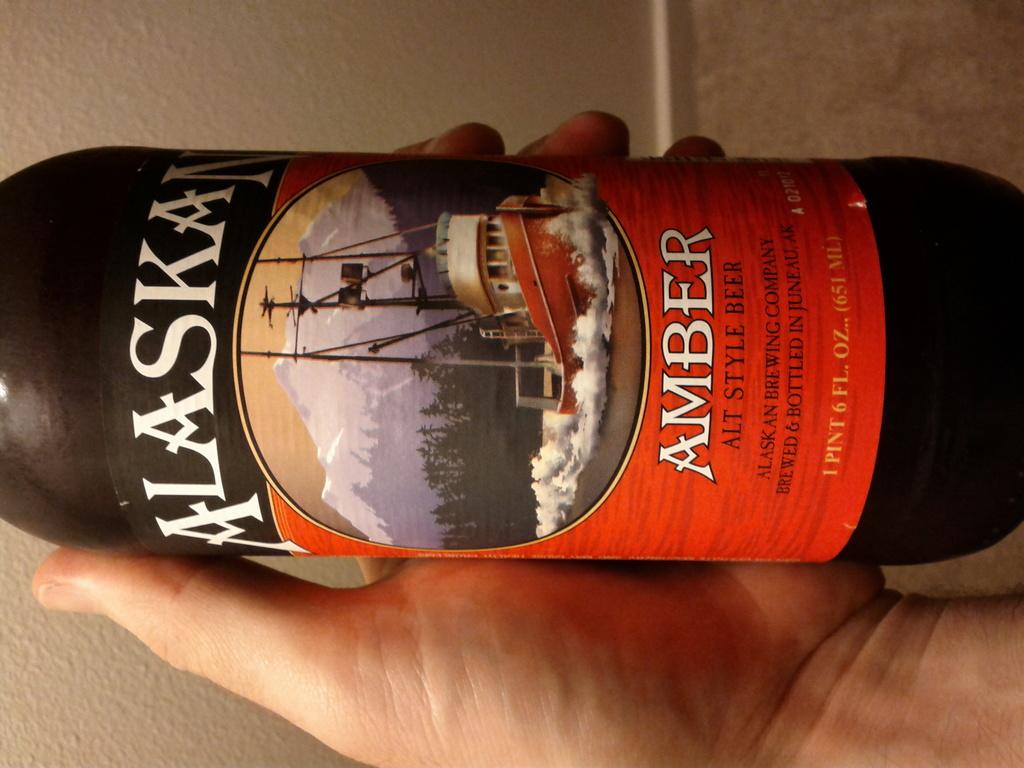What american state is named on this label?
Offer a terse response. Alaska. 